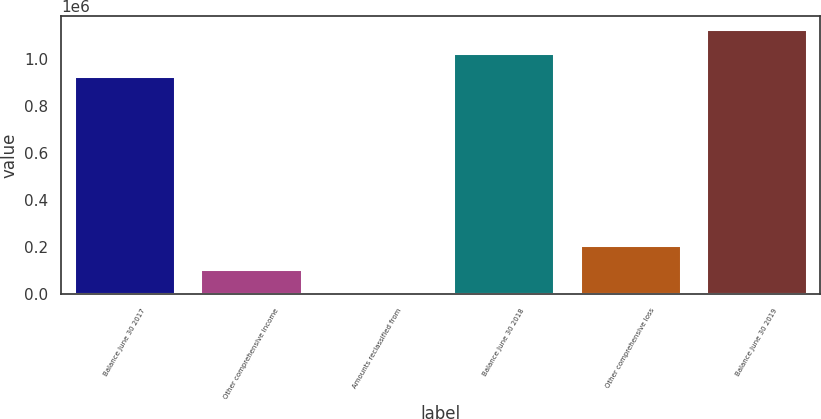<chart> <loc_0><loc_0><loc_500><loc_500><bar_chart><fcel>Balance June 30 2017<fcel>Other comprehensive income<fcel>Amounts reclassified from<fcel>Balance June 30 2018<fcel>Other comprehensive loss<fcel>Balance June 30 2019<nl><fcel>925342<fcel>108360<fcel>7994<fcel>1.02571e+06<fcel>208726<fcel>1.12607e+06<nl></chart> 